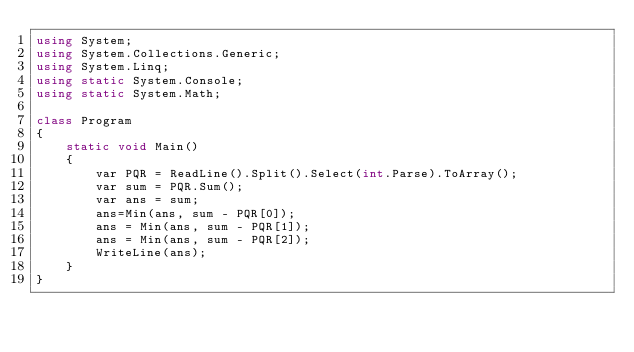<code> <loc_0><loc_0><loc_500><loc_500><_C#_>using System;
using System.Collections.Generic;
using System.Linq;
using static System.Console;
using static System.Math;

class Program
{
    static void Main()
    {
        var PQR = ReadLine().Split().Select(int.Parse).ToArray();
        var sum = PQR.Sum();
        var ans = sum;
        ans=Min(ans, sum - PQR[0]);
        ans = Min(ans, sum - PQR[1]);
        ans = Min(ans, sum - PQR[2]);
        WriteLine(ans);
    }
}</code> 